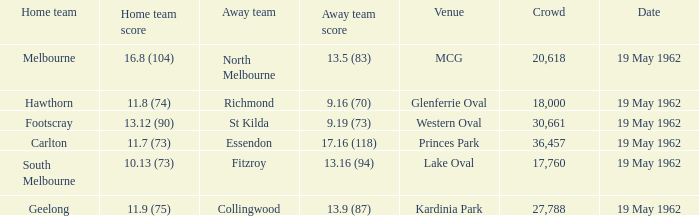Can you tell me the home team's score at the mcg? 16.8 (104). 